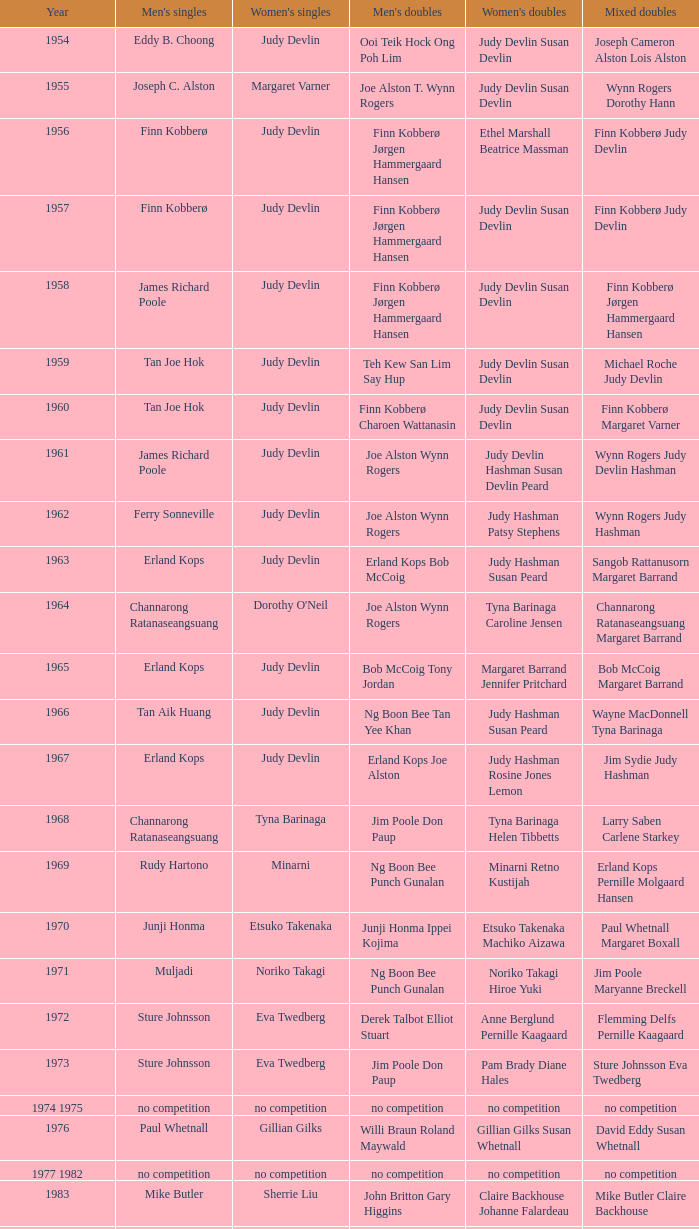Write the full table. {'header': ['Year', "Men's singles", "Women's singles", "Men's doubles", "Women's doubles", 'Mixed doubles'], 'rows': [['1954', 'Eddy B. Choong', 'Judy Devlin', 'Ooi Teik Hock Ong Poh Lim', 'Judy Devlin Susan Devlin', 'Joseph Cameron Alston Lois Alston'], ['1955', 'Joseph C. Alston', 'Margaret Varner', 'Joe Alston T. Wynn Rogers', 'Judy Devlin Susan Devlin', 'Wynn Rogers Dorothy Hann'], ['1956', 'Finn Kobberø', 'Judy Devlin', 'Finn Kobberø Jørgen Hammergaard Hansen', 'Ethel Marshall Beatrice Massman', 'Finn Kobberø Judy Devlin'], ['1957', 'Finn Kobberø', 'Judy Devlin', 'Finn Kobberø Jørgen Hammergaard Hansen', 'Judy Devlin Susan Devlin', 'Finn Kobberø Judy Devlin'], ['1958', 'James Richard Poole', 'Judy Devlin', 'Finn Kobberø Jørgen Hammergaard Hansen', 'Judy Devlin Susan Devlin', 'Finn Kobberø Jørgen Hammergaard Hansen'], ['1959', 'Tan Joe Hok', 'Judy Devlin', 'Teh Kew San Lim Say Hup', 'Judy Devlin Susan Devlin', 'Michael Roche Judy Devlin'], ['1960', 'Tan Joe Hok', 'Judy Devlin', 'Finn Kobberø Charoen Wattanasin', 'Judy Devlin Susan Devlin', 'Finn Kobberø Margaret Varner'], ['1961', 'James Richard Poole', 'Judy Devlin', 'Joe Alston Wynn Rogers', 'Judy Devlin Hashman Susan Devlin Peard', 'Wynn Rogers Judy Devlin Hashman'], ['1962', 'Ferry Sonneville', 'Judy Devlin', 'Joe Alston Wynn Rogers', 'Judy Hashman Patsy Stephens', 'Wynn Rogers Judy Hashman'], ['1963', 'Erland Kops', 'Judy Devlin', 'Erland Kops Bob McCoig', 'Judy Hashman Susan Peard', 'Sangob Rattanusorn Margaret Barrand'], ['1964', 'Channarong Ratanaseangsuang', "Dorothy O'Neil", 'Joe Alston Wynn Rogers', 'Tyna Barinaga Caroline Jensen', 'Channarong Ratanaseangsuang Margaret Barrand'], ['1965', 'Erland Kops', 'Judy Devlin', 'Bob McCoig Tony Jordan', 'Margaret Barrand Jennifer Pritchard', 'Bob McCoig Margaret Barrand'], ['1966', 'Tan Aik Huang', 'Judy Devlin', 'Ng Boon Bee Tan Yee Khan', 'Judy Hashman Susan Peard', 'Wayne MacDonnell Tyna Barinaga'], ['1967', 'Erland Kops', 'Judy Devlin', 'Erland Kops Joe Alston', 'Judy Hashman Rosine Jones Lemon', 'Jim Sydie Judy Hashman'], ['1968', 'Channarong Ratanaseangsuang', 'Tyna Barinaga', 'Jim Poole Don Paup', 'Tyna Barinaga Helen Tibbetts', 'Larry Saben Carlene Starkey'], ['1969', 'Rudy Hartono', 'Minarni', 'Ng Boon Bee Punch Gunalan', 'Minarni Retno Kustijah', 'Erland Kops Pernille Molgaard Hansen'], ['1970', 'Junji Honma', 'Etsuko Takenaka', 'Junji Honma Ippei Kojima', 'Etsuko Takenaka Machiko Aizawa', 'Paul Whetnall Margaret Boxall'], ['1971', 'Muljadi', 'Noriko Takagi', 'Ng Boon Bee Punch Gunalan', 'Noriko Takagi Hiroe Yuki', 'Jim Poole Maryanne Breckell'], ['1972', 'Sture Johnsson', 'Eva Twedberg', 'Derek Talbot Elliot Stuart', 'Anne Berglund Pernille Kaagaard', 'Flemming Delfs Pernille Kaagaard'], ['1973', 'Sture Johnsson', 'Eva Twedberg', 'Jim Poole Don Paup', 'Pam Brady Diane Hales', 'Sture Johnsson Eva Twedberg'], ['1974 1975', 'no competition', 'no competition', 'no competition', 'no competition', 'no competition'], ['1976', 'Paul Whetnall', 'Gillian Gilks', 'Willi Braun Roland Maywald', 'Gillian Gilks Susan Whetnall', 'David Eddy Susan Whetnall'], ['1977 1982', 'no competition', 'no competition', 'no competition', 'no competition', 'no competition'], ['1983', 'Mike Butler', 'Sherrie Liu', 'John Britton Gary Higgins', 'Claire Backhouse Johanne Falardeau', 'Mike Butler Claire Backhouse'], ['1984', 'Xiong Guobao', 'Luo Yun', 'Chen Hongyong Zhang Qingwu', 'Yin Haichen Lu Yanahua', 'Wang Pengren Luo Yun'], ['1985', 'Mike Butler', 'Claire Backhouse Sharpe', 'John Britton Gary Higgins', 'Claire Sharpe Sandra Skillings', 'Mike Butler Claire Sharpe'], ['1986', 'Sung Han-kuk', 'Denyse Julien', 'Yao Ximing Tariq Wadood', 'Denyse Julien Johanne Falardeau', 'Mike Butler Johanne Falardeau'], ['1987', 'Park Sun-bae', 'Chun Suk-sun', 'Lee Deuk-choon Lee Sang-bok', 'Kim Ho Ja Chung So-young', 'Lee Deuk-choon Chung So-young'], ['1988', 'Sze Yu', 'Lee Myeong-hee', 'Christian Hadinata Lius Pongoh', 'Kim Ho Ja Chung So-young', 'Christian Hadinata Ivana Lie'], ['1989', 'no competition', 'no competition', 'no competition', 'no competition', 'no competition'], ['1990', 'Fung Permadi', 'Denyse Julien', 'Ger Shin-Ming Yang Shih-Jeng', 'Denyse Julien Doris Piché', 'Tariq Wadood Traci Britton'], ['1991', 'Steve Butler', 'Shim Eun-jung', 'Jalani Sidek Razif Sidek', 'Shim Eun-jung Kang Bok-seung', 'Lee Sang-bok Shim Eun-jung'], ['1992', 'Poul-Erik Hoyer-Larsen', 'Lim Xiaoqing', 'Cheah Soon Kit Soo Beng Kiang', 'Lim Xiaoqing Christine Magnusson', 'Thomas Lund Pernille Dupont'], ['1993', 'Marleve Mainaky', 'Lim Xiaoqing', 'Thomas Lund Jon Holst-Christensen', 'Gil Young-ah Chung So-young', 'Thomas Lund Catrine Bengtsson'], ['1994', 'Thomas Stuer-Lauridsen', 'Liu Guimei', 'Ade Sutrisna Candra Wijaya', 'Rikke Olsen Helene Kirkegaard', 'Jens Eriksen Rikke Olsen'], ['1995', 'Hermawan Susanto', 'Ye Zhaoying', 'Rudy Gunawan Joko Suprianto', 'Gil Young-ah Jang Hye-ock', 'Kim Dong-moon Gil Young-ah'], ['1996', 'Joko Suprianto', 'Mia Audina', 'Candra Wijaya Sigit Budiarto', 'Zelin Resiana Eliza Nathanael', 'Kim Dong-moon Chung So-young'], ['1997', 'Poul-Erik Hoyer-Larsen', 'Camilla Martin', 'Ha Tae-kwon Kim Dong-moon', 'Qin Yiyuan Tang Yongshu', 'Kim Dong Moon Ra Kyung-min'], ['1998', 'Fung Permadi', 'Tang Yeping', 'Horng Shin-Jeng Lee Wei-Jen', 'Elinor Middlemiss Kirsteen McEwan', 'Kenny Middlemiss Elinor Middlemiss'], ['1999', 'Colin Haughton', 'Pi Hongyan', 'Michael Lamp Jonas Rasmussen', 'Huang Nanyan Lu Ying', 'Jonas Rasmussen Jane F. Bramsen'], ['2000', 'Ardy Wiranata', 'Choi Ma-re', 'Graham Hurrell James Anderson', 'Gail Emms Joanne Wright', 'Jonas Rasmussen Jane F. Bramsen'], ['2001', 'Lee Hyun-il', 'Ra Kyung-min', 'Kang Kyung-jin Park Young-duk', 'Kim Kyeung-ran Ra Kyung-min', 'Mathias Boe Majken Vange'], ['2002', 'Peter Gade', 'Julia Mann', 'Tony Gunawan Khan Malaythong', 'Joanne Wright Natalie Munt', 'Tony Gunawan Etty Tantri'], ['2003', 'Chien Yu-hsiu', 'Kelly Morgan', 'Tony Gunawan Khan Malaythong', 'Yoshiko Iwata Miyuki Tai', 'Tony Gunawan Eti Gunawan'], ['2004', 'Kendrick Lee Yen Hui', 'Xing Aiying', 'Howard Bach Tony Gunawan', 'Cheng Wen-hsing Chien Yu-chin', 'Lin Wei-hsiang Cheng Wen-hsing'], ['2005', 'Hsieh Yu-hsing', 'Lili Zhou', 'Howard Bach Tony Gunawan', 'Peng Yun Johanna Lee', 'Khan Malaythong Mesinee Mangkalakiri'], ['2006', 'Yousuke Nakanishi', 'Ella Karachkova', 'Halim Haryanto Tony Gunawan', 'Nina Vislova Valeria Sorokina', 'Sergey Ivlev Nina Vislova'], ['2007', 'Lee Tsuen Seng', 'Jun Jae-youn', 'Tadashi Ohtsuka Keita Masuda', 'Miyuki Maeda Satoko Suetsuna', 'Keita Masuda Miyuki Maeda'], ['2008', 'Andrew Dabeka', 'Lili Zhou', 'Howard Bach Khan Malaythong', 'Chang Li-Ying Hung Shih-Chieh', 'Halim Haryanto Peng Yun'], ['2009', 'Taufik Hidayat', 'Anna Rice', 'Howard Bach Tony Gunawan', 'Ruilin Huang Xuelian Jiang', 'Howard Bach Eva Lee'], ['2010', 'Rajiv Ouseph', 'Zhu Lin', 'Fang Chieh-min Lee Sheng-mu', 'Cheng Wen-hsing Chien Yu-chin', 'Michael Fuchs Birgit Overzier'], ['2011', 'Sho Sasaki', 'Tai Tzu-ying', 'Ko Sung-hyun Lee Yong-dae', 'Ha Jung-eun Kim Min-jung', 'Lee Yong-dae Ha Jung-eun'], ['2012', 'Vladimir Ivanov', 'Pai Hsiao-ma', 'Hiroyuki Endo Kenichi Hayakawa', 'Misaki Matsutomo Ayaka Takahashi', 'Tony Gunawan Vita Marissa'], ['2013', 'Nguyen Tien Minh', 'Sapsiree Taerattanachai', 'Takeshi Kamura Keigo Sonoda', 'Bao Yixin Zhong Qianxin', 'Lee Chun Hei Chau Hoi Wah']]} Who was the female singles winner in 1984? Luo Yun. 